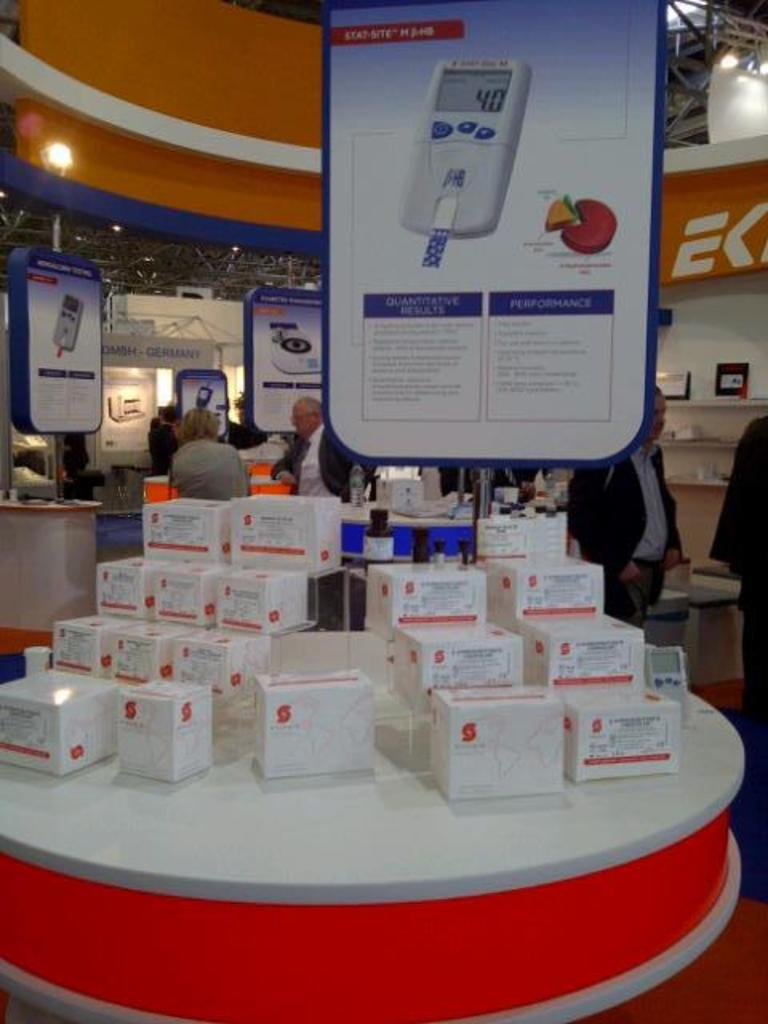<image>
Create a compact narrative representing the image presented. a sign with the letter K in the back of a store 